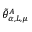<formula> <loc_0><loc_0><loc_500><loc_500>\tilde { \theta } _ { \alpha , L , \mu } ^ { A }</formula> 